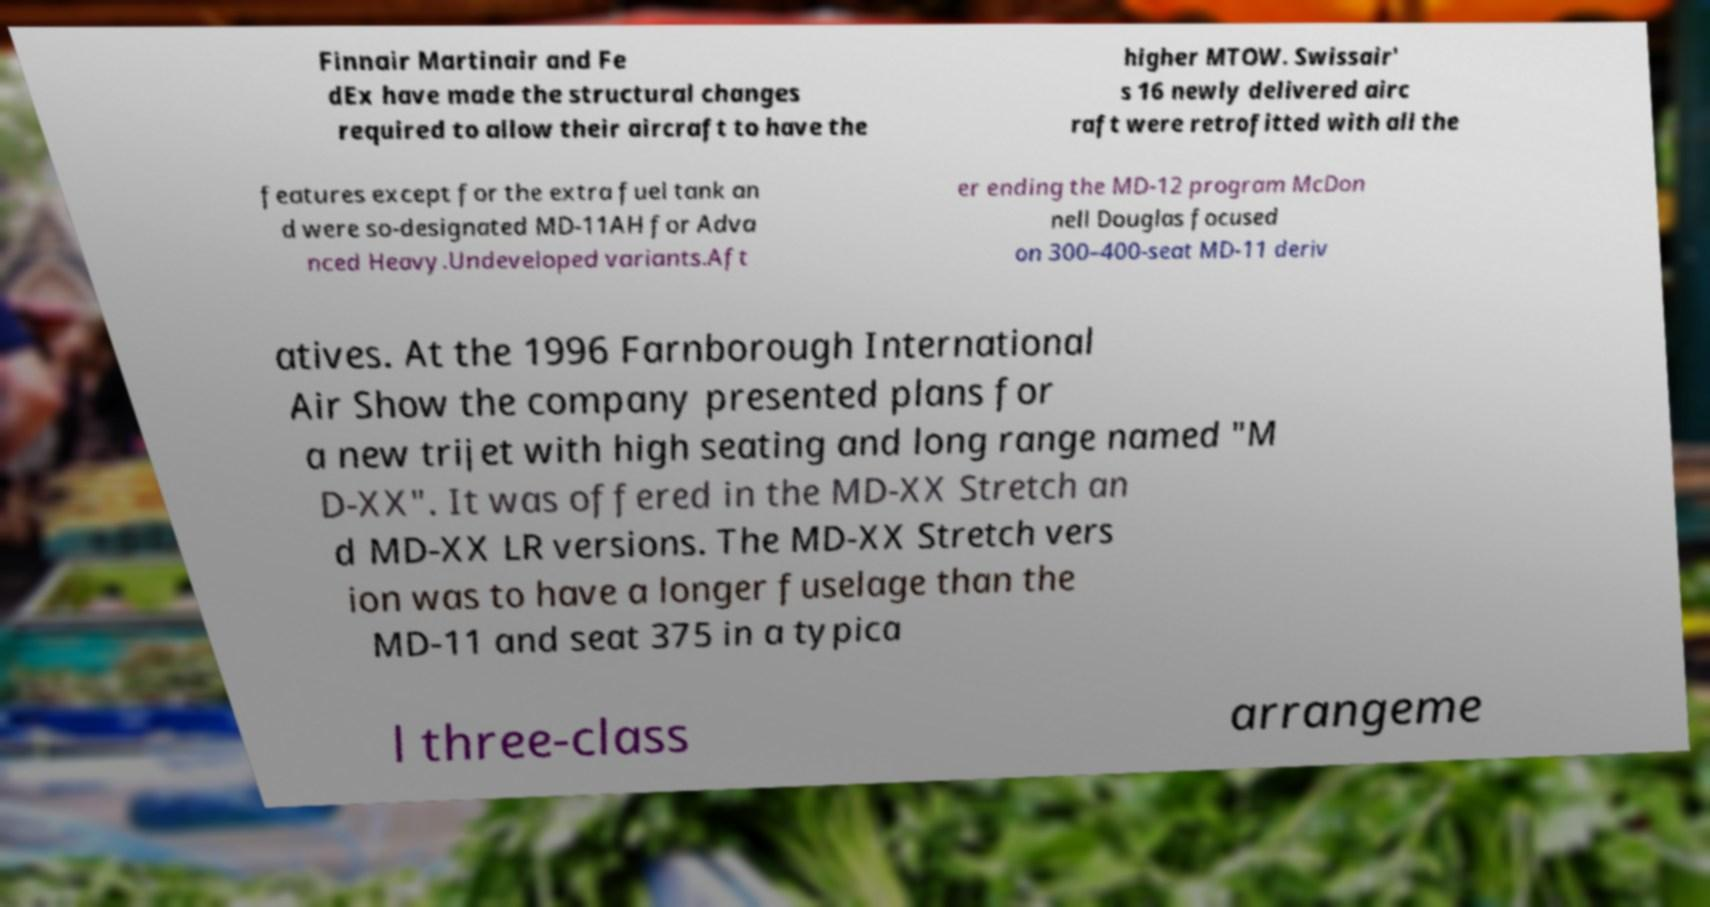Could you extract and type out the text from this image? Finnair Martinair and Fe dEx have made the structural changes required to allow their aircraft to have the higher MTOW. Swissair' s 16 newly delivered airc raft were retrofitted with all the features except for the extra fuel tank an d were so-designated MD-11AH for Adva nced Heavy.Undeveloped variants.Aft er ending the MD-12 program McDon nell Douglas focused on 300–400-seat MD-11 deriv atives. At the 1996 Farnborough International Air Show the company presented plans for a new trijet with high seating and long range named "M D-XX". It was offered in the MD-XX Stretch an d MD-XX LR versions. The MD-XX Stretch vers ion was to have a longer fuselage than the MD-11 and seat 375 in a typica l three-class arrangeme 